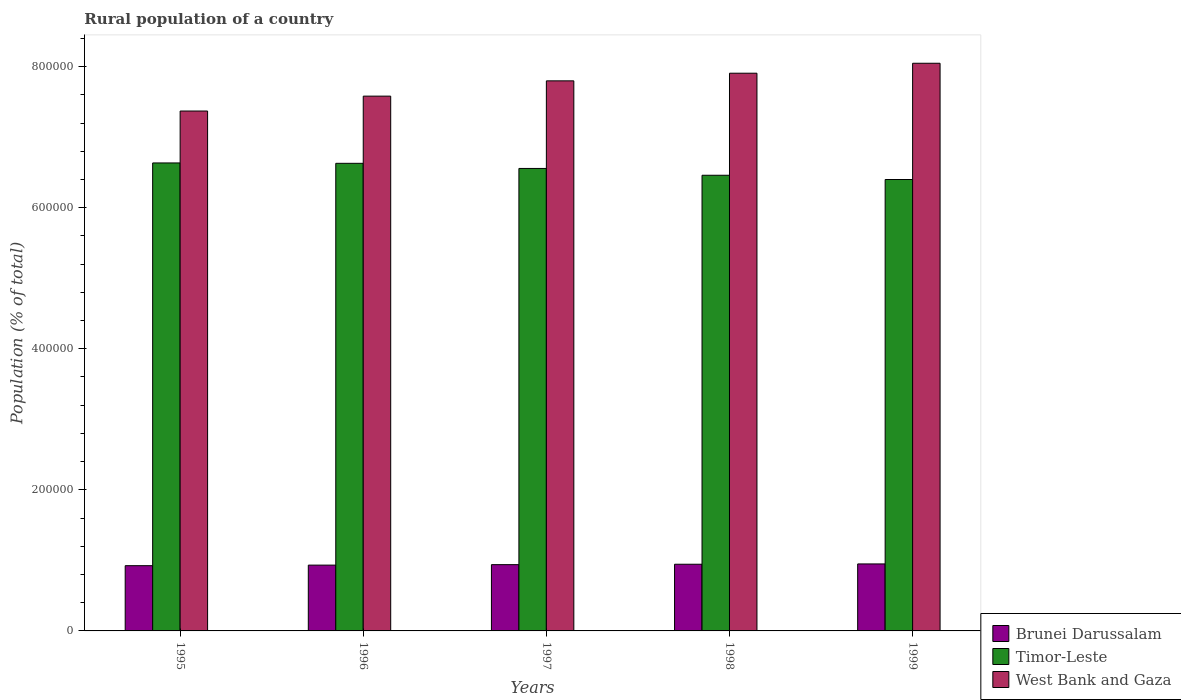How many different coloured bars are there?
Offer a very short reply. 3. How many groups of bars are there?
Give a very brief answer. 5. Are the number of bars on each tick of the X-axis equal?
Offer a very short reply. Yes. How many bars are there on the 4th tick from the left?
Ensure brevity in your answer.  3. How many bars are there on the 1st tick from the right?
Offer a very short reply. 3. In how many cases, is the number of bars for a given year not equal to the number of legend labels?
Provide a succinct answer. 0. What is the rural population in West Bank and Gaza in 1999?
Your answer should be compact. 8.05e+05. Across all years, what is the maximum rural population in Brunei Darussalam?
Your answer should be very brief. 9.50e+04. Across all years, what is the minimum rural population in Brunei Darussalam?
Make the answer very short. 9.25e+04. In which year was the rural population in Brunei Darussalam maximum?
Provide a short and direct response. 1999. What is the total rural population in Timor-Leste in the graph?
Offer a terse response. 3.27e+06. What is the difference between the rural population in Timor-Leste in 1996 and that in 1999?
Ensure brevity in your answer.  2.29e+04. What is the difference between the rural population in Timor-Leste in 1998 and the rural population in West Bank and Gaza in 1999?
Your answer should be compact. -1.59e+05. What is the average rural population in West Bank and Gaza per year?
Keep it short and to the point. 7.74e+05. In the year 1996, what is the difference between the rural population in West Bank and Gaza and rural population in Brunei Darussalam?
Offer a terse response. 6.65e+05. What is the ratio of the rural population in West Bank and Gaza in 1995 to that in 1997?
Your answer should be very brief. 0.95. Is the rural population in Timor-Leste in 1997 less than that in 1999?
Ensure brevity in your answer.  No. Is the difference between the rural population in West Bank and Gaza in 1995 and 1998 greater than the difference between the rural population in Brunei Darussalam in 1995 and 1998?
Your answer should be compact. No. What is the difference between the highest and the second highest rural population in West Bank and Gaza?
Keep it short and to the point. 1.41e+04. What is the difference between the highest and the lowest rural population in Brunei Darussalam?
Your answer should be very brief. 2474. What does the 1st bar from the left in 1995 represents?
Ensure brevity in your answer.  Brunei Darussalam. What does the 1st bar from the right in 1995 represents?
Keep it short and to the point. West Bank and Gaza. Is it the case that in every year, the sum of the rural population in West Bank and Gaza and rural population in Timor-Leste is greater than the rural population in Brunei Darussalam?
Provide a short and direct response. Yes. Are all the bars in the graph horizontal?
Your answer should be compact. No. Are the values on the major ticks of Y-axis written in scientific E-notation?
Provide a succinct answer. No. Does the graph contain grids?
Keep it short and to the point. No. Where does the legend appear in the graph?
Give a very brief answer. Bottom right. How many legend labels are there?
Provide a succinct answer. 3. What is the title of the graph?
Ensure brevity in your answer.  Rural population of a country. What is the label or title of the X-axis?
Offer a very short reply. Years. What is the label or title of the Y-axis?
Offer a very short reply. Population (% of total). What is the Population (% of total) of Brunei Darussalam in 1995?
Offer a terse response. 9.25e+04. What is the Population (% of total) of Timor-Leste in 1995?
Offer a very short reply. 6.63e+05. What is the Population (% of total) in West Bank and Gaza in 1995?
Keep it short and to the point. 7.37e+05. What is the Population (% of total) in Brunei Darussalam in 1996?
Keep it short and to the point. 9.33e+04. What is the Population (% of total) in Timor-Leste in 1996?
Your response must be concise. 6.63e+05. What is the Population (% of total) of West Bank and Gaza in 1996?
Your answer should be compact. 7.58e+05. What is the Population (% of total) of Brunei Darussalam in 1997?
Make the answer very short. 9.40e+04. What is the Population (% of total) in Timor-Leste in 1997?
Ensure brevity in your answer.  6.56e+05. What is the Population (% of total) of West Bank and Gaza in 1997?
Your answer should be compact. 7.80e+05. What is the Population (% of total) of Brunei Darussalam in 1998?
Your answer should be very brief. 9.45e+04. What is the Population (% of total) in Timor-Leste in 1998?
Give a very brief answer. 6.46e+05. What is the Population (% of total) of West Bank and Gaza in 1998?
Your response must be concise. 7.91e+05. What is the Population (% of total) in Brunei Darussalam in 1999?
Offer a terse response. 9.50e+04. What is the Population (% of total) of Timor-Leste in 1999?
Ensure brevity in your answer.  6.40e+05. What is the Population (% of total) of West Bank and Gaza in 1999?
Your answer should be compact. 8.05e+05. Across all years, what is the maximum Population (% of total) of Brunei Darussalam?
Make the answer very short. 9.50e+04. Across all years, what is the maximum Population (% of total) of Timor-Leste?
Offer a terse response. 6.63e+05. Across all years, what is the maximum Population (% of total) of West Bank and Gaza?
Give a very brief answer. 8.05e+05. Across all years, what is the minimum Population (% of total) of Brunei Darussalam?
Your answer should be very brief. 9.25e+04. Across all years, what is the minimum Population (% of total) of Timor-Leste?
Make the answer very short. 6.40e+05. Across all years, what is the minimum Population (% of total) of West Bank and Gaza?
Provide a short and direct response. 7.37e+05. What is the total Population (% of total) of Brunei Darussalam in the graph?
Your response must be concise. 4.69e+05. What is the total Population (% of total) of Timor-Leste in the graph?
Ensure brevity in your answer.  3.27e+06. What is the total Population (% of total) of West Bank and Gaza in the graph?
Offer a very short reply. 3.87e+06. What is the difference between the Population (% of total) of Brunei Darussalam in 1995 and that in 1996?
Provide a short and direct response. -778. What is the difference between the Population (% of total) in Timor-Leste in 1995 and that in 1996?
Make the answer very short. 546. What is the difference between the Population (% of total) of West Bank and Gaza in 1995 and that in 1996?
Offer a terse response. -2.11e+04. What is the difference between the Population (% of total) in Brunei Darussalam in 1995 and that in 1997?
Provide a short and direct response. -1455. What is the difference between the Population (% of total) in Timor-Leste in 1995 and that in 1997?
Your answer should be very brief. 7807. What is the difference between the Population (% of total) in West Bank and Gaza in 1995 and that in 1997?
Provide a succinct answer. -4.28e+04. What is the difference between the Population (% of total) of Brunei Darussalam in 1995 and that in 1998?
Your answer should be compact. -2020. What is the difference between the Population (% of total) of Timor-Leste in 1995 and that in 1998?
Offer a terse response. 1.75e+04. What is the difference between the Population (% of total) of West Bank and Gaza in 1995 and that in 1998?
Give a very brief answer. -5.36e+04. What is the difference between the Population (% of total) of Brunei Darussalam in 1995 and that in 1999?
Offer a terse response. -2474. What is the difference between the Population (% of total) of Timor-Leste in 1995 and that in 1999?
Your answer should be very brief. 2.35e+04. What is the difference between the Population (% of total) in West Bank and Gaza in 1995 and that in 1999?
Your response must be concise. -6.77e+04. What is the difference between the Population (% of total) in Brunei Darussalam in 1996 and that in 1997?
Offer a terse response. -677. What is the difference between the Population (% of total) in Timor-Leste in 1996 and that in 1997?
Your response must be concise. 7261. What is the difference between the Population (% of total) of West Bank and Gaza in 1996 and that in 1997?
Provide a succinct answer. -2.17e+04. What is the difference between the Population (% of total) in Brunei Darussalam in 1996 and that in 1998?
Offer a very short reply. -1242. What is the difference between the Population (% of total) in Timor-Leste in 1996 and that in 1998?
Ensure brevity in your answer.  1.69e+04. What is the difference between the Population (% of total) of West Bank and Gaza in 1996 and that in 1998?
Your answer should be compact. -3.25e+04. What is the difference between the Population (% of total) of Brunei Darussalam in 1996 and that in 1999?
Give a very brief answer. -1696. What is the difference between the Population (% of total) in Timor-Leste in 1996 and that in 1999?
Provide a succinct answer. 2.29e+04. What is the difference between the Population (% of total) in West Bank and Gaza in 1996 and that in 1999?
Your answer should be compact. -4.66e+04. What is the difference between the Population (% of total) of Brunei Darussalam in 1997 and that in 1998?
Give a very brief answer. -565. What is the difference between the Population (% of total) in Timor-Leste in 1997 and that in 1998?
Provide a succinct answer. 9651. What is the difference between the Population (% of total) of West Bank and Gaza in 1997 and that in 1998?
Your answer should be very brief. -1.08e+04. What is the difference between the Population (% of total) in Brunei Darussalam in 1997 and that in 1999?
Offer a very short reply. -1019. What is the difference between the Population (% of total) of Timor-Leste in 1997 and that in 1999?
Keep it short and to the point. 1.57e+04. What is the difference between the Population (% of total) in West Bank and Gaza in 1997 and that in 1999?
Keep it short and to the point. -2.49e+04. What is the difference between the Population (% of total) in Brunei Darussalam in 1998 and that in 1999?
Your answer should be very brief. -454. What is the difference between the Population (% of total) of Timor-Leste in 1998 and that in 1999?
Ensure brevity in your answer.  6026. What is the difference between the Population (% of total) in West Bank and Gaza in 1998 and that in 1999?
Offer a very short reply. -1.41e+04. What is the difference between the Population (% of total) in Brunei Darussalam in 1995 and the Population (% of total) in Timor-Leste in 1996?
Keep it short and to the point. -5.70e+05. What is the difference between the Population (% of total) in Brunei Darussalam in 1995 and the Population (% of total) in West Bank and Gaza in 1996?
Make the answer very short. -6.66e+05. What is the difference between the Population (% of total) of Timor-Leste in 1995 and the Population (% of total) of West Bank and Gaza in 1996?
Your response must be concise. -9.47e+04. What is the difference between the Population (% of total) in Brunei Darussalam in 1995 and the Population (% of total) in Timor-Leste in 1997?
Your answer should be compact. -5.63e+05. What is the difference between the Population (% of total) in Brunei Darussalam in 1995 and the Population (% of total) in West Bank and Gaza in 1997?
Offer a very short reply. -6.87e+05. What is the difference between the Population (% of total) of Timor-Leste in 1995 and the Population (% of total) of West Bank and Gaza in 1997?
Make the answer very short. -1.16e+05. What is the difference between the Population (% of total) of Brunei Darussalam in 1995 and the Population (% of total) of Timor-Leste in 1998?
Offer a terse response. -5.53e+05. What is the difference between the Population (% of total) in Brunei Darussalam in 1995 and the Population (% of total) in West Bank and Gaza in 1998?
Offer a terse response. -6.98e+05. What is the difference between the Population (% of total) in Timor-Leste in 1995 and the Population (% of total) in West Bank and Gaza in 1998?
Give a very brief answer. -1.27e+05. What is the difference between the Population (% of total) of Brunei Darussalam in 1995 and the Population (% of total) of Timor-Leste in 1999?
Provide a short and direct response. -5.47e+05. What is the difference between the Population (% of total) of Brunei Darussalam in 1995 and the Population (% of total) of West Bank and Gaza in 1999?
Make the answer very short. -7.12e+05. What is the difference between the Population (% of total) of Timor-Leste in 1995 and the Population (% of total) of West Bank and Gaza in 1999?
Give a very brief answer. -1.41e+05. What is the difference between the Population (% of total) in Brunei Darussalam in 1996 and the Population (% of total) in Timor-Leste in 1997?
Your answer should be compact. -5.62e+05. What is the difference between the Population (% of total) of Brunei Darussalam in 1996 and the Population (% of total) of West Bank and Gaza in 1997?
Offer a terse response. -6.87e+05. What is the difference between the Population (% of total) in Timor-Leste in 1996 and the Population (% of total) in West Bank and Gaza in 1997?
Offer a terse response. -1.17e+05. What is the difference between the Population (% of total) in Brunei Darussalam in 1996 and the Population (% of total) in Timor-Leste in 1998?
Your answer should be compact. -5.53e+05. What is the difference between the Population (% of total) in Brunei Darussalam in 1996 and the Population (% of total) in West Bank and Gaza in 1998?
Offer a terse response. -6.97e+05. What is the difference between the Population (% of total) of Timor-Leste in 1996 and the Population (% of total) of West Bank and Gaza in 1998?
Provide a succinct answer. -1.28e+05. What is the difference between the Population (% of total) in Brunei Darussalam in 1996 and the Population (% of total) in Timor-Leste in 1999?
Your answer should be compact. -5.47e+05. What is the difference between the Population (% of total) in Brunei Darussalam in 1996 and the Population (% of total) in West Bank and Gaza in 1999?
Provide a short and direct response. -7.11e+05. What is the difference between the Population (% of total) in Timor-Leste in 1996 and the Population (% of total) in West Bank and Gaza in 1999?
Provide a succinct answer. -1.42e+05. What is the difference between the Population (% of total) in Brunei Darussalam in 1997 and the Population (% of total) in Timor-Leste in 1998?
Give a very brief answer. -5.52e+05. What is the difference between the Population (% of total) of Brunei Darussalam in 1997 and the Population (% of total) of West Bank and Gaza in 1998?
Give a very brief answer. -6.97e+05. What is the difference between the Population (% of total) of Timor-Leste in 1997 and the Population (% of total) of West Bank and Gaza in 1998?
Give a very brief answer. -1.35e+05. What is the difference between the Population (% of total) of Brunei Darussalam in 1997 and the Population (% of total) of Timor-Leste in 1999?
Your response must be concise. -5.46e+05. What is the difference between the Population (% of total) of Brunei Darussalam in 1997 and the Population (% of total) of West Bank and Gaza in 1999?
Your answer should be very brief. -7.11e+05. What is the difference between the Population (% of total) of Timor-Leste in 1997 and the Population (% of total) of West Bank and Gaza in 1999?
Provide a succinct answer. -1.49e+05. What is the difference between the Population (% of total) of Brunei Darussalam in 1998 and the Population (% of total) of Timor-Leste in 1999?
Offer a very short reply. -5.45e+05. What is the difference between the Population (% of total) of Brunei Darussalam in 1998 and the Population (% of total) of West Bank and Gaza in 1999?
Your answer should be very brief. -7.10e+05. What is the difference between the Population (% of total) of Timor-Leste in 1998 and the Population (% of total) of West Bank and Gaza in 1999?
Your response must be concise. -1.59e+05. What is the average Population (% of total) in Brunei Darussalam per year?
Provide a succinct answer. 9.38e+04. What is the average Population (% of total) in Timor-Leste per year?
Your answer should be compact. 6.54e+05. What is the average Population (% of total) in West Bank and Gaza per year?
Offer a very short reply. 7.74e+05. In the year 1995, what is the difference between the Population (% of total) of Brunei Darussalam and Population (% of total) of Timor-Leste?
Offer a very short reply. -5.71e+05. In the year 1995, what is the difference between the Population (% of total) in Brunei Darussalam and Population (% of total) in West Bank and Gaza?
Make the answer very short. -6.45e+05. In the year 1995, what is the difference between the Population (% of total) of Timor-Leste and Population (% of total) of West Bank and Gaza?
Offer a terse response. -7.36e+04. In the year 1996, what is the difference between the Population (% of total) in Brunei Darussalam and Population (% of total) in Timor-Leste?
Keep it short and to the point. -5.70e+05. In the year 1996, what is the difference between the Population (% of total) in Brunei Darussalam and Population (% of total) in West Bank and Gaza?
Your response must be concise. -6.65e+05. In the year 1996, what is the difference between the Population (% of total) in Timor-Leste and Population (% of total) in West Bank and Gaza?
Offer a very short reply. -9.53e+04. In the year 1997, what is the difference between the Population (% of total) in Brunei Darussalam and Population (% of total) in Timor-Leste?
Your answer should be compact. -5.62e+05. In the year 1997, what is the difference between the Population (% of total) in Brunei Darussalam and Population (% of total) in West Bank and Gaza?
Provide a succinct answer. -6.86e+05. In the year 1997, what is the difference between the Population (% of total) of Timor-Leste and Population (% of total) of West Bank and Gaza?
Ensure brevity in your answer.  -1.24e+05. In the year 1998, what is the difference between the Population (% of total) of Brunei Darussalam and Population (% of total) of Timor-Leste?
Your answer should be very brief. -5.51e+05. In the year 1998, what is the difference between the Population (% of total) in Brunei Darussalam and Population (% of total) in West Bank and Gaza?
Offer a terse response. -6.96e+05. In the year 1998, what is the difference between the Population (% of total) in Timor-Leste and Population (% of total) in West Bank and Gaza?
Provide a short and direct response. -1.45e+05. In the year 1999, what is the difference between the Population (% of total) of Brunei Darussalam and Population (% of total) of Timor-Leste?
Ensure brevity in your answer.  -5.45e+05. In the year 1999, what is the difference between the Population (% of total) in Brunei Darussalam and Population (% of total) in West Bank and Gaza?
Make the answer very short. -7.10e+05. In the year 1999, what is the difference between the Population (% of total) of Timor-Leste and Population (% of total) of West Bank and Gaza?
Offer a very short reply. -1.65e+05. What is the ratio of the Population (% of total) of West Bank and Gaza in 1995 to that in 1996?
Your answer should be compact. 0.97. What is the ratio of the Population (% of total) in Brunei Darussalam in 1995 to that in 1997?
Give a very brief answer. 0.98. What is the ratio of the Population (% of total) in Timor-Leste in 1995 to that in 1997?
Your response must be concise. 1.01. What is the ratio of the Population (% of total) in West Bank and Gaza in 1995 to that in 1997?
Offer a very short reply. 0.95. What is the ratio of the Population (% of total) of Brunei Darussalam in 1995 to that in 1998?
Your response must be concise. 0.98. What is the ratio of the Population (% of total) in Timor-Leste in 1995 to that in 1998?
Ensure brevity in your answer.  1.03. What is the ratio of the Population (% of total) in West Bank and Gaza in 1995 to that in 1998?
Your response must be concise. 0.93. What is the ratio of the Population (% of total) of Timor-Leste in 1995 to that in 1999?
Give a very brief answer. 1.04. What is the ratio of the Population (% of total) in West Bank and Gaza in 1995 to that in 1999?
Give a very brief answer. 0.92. What is the ratio of the Population (% of total) in Timor-Leste in 1996 to that in 1997?
Offer a terse response. 1.01. What is the ratio of the Population (% of total) of West Bank and Gaza in 1996 to that in 1997?
Offer a very short reply. 0.97. What is the ratio of the Population (% of total) of Brunei Darussalam in 1996 to that in 1998?
Ensure brevity in your answer.  0.99. What is the ratio of the Population (% of total) of Timor-Leste in 1996 to that in 1998?
Offer a terse response. 1.03. What is the ratio of the Population (% of total) of West Bank and Gaza in 1996 to that in 1998?
Provide a short and direct response. 0.96. What is the ratio of the Population (% of total) in Brunei Darussalam in 1996 to that in 1999?
Make the answer very short. 0.98. What is the ratio of the Population (% of total) of Timor-Leste in 1996 to that in 1999?
Offer a very short reply. 1.04. What is the ratio of the Population (% of total) in West Bank and Gaza in 1996 to that in 1999?
Provide a succinct answer. 0.94. What is the ratio of the Population (% of total) in Brunei Darussalam in 1997 to that in 1998?
Offer a terse response. 0.99. What is the ratio of the Population (% of total) of Timor-Leste in 1997 to that in 1998?
Give a very brief answer. 1.01. What is the ratio of the Population (% of total) of West Bank and Gaza in 1997 to that in 1998?
Give a very brief answer. 0.99. What is the ratio of the Population (% of total) of Brunei Darussalam in 1997 to that in 1999?
Offer a terse response. 0.99. What is the ratio of the Population (% of total) of Timor-Leste in 1997 to that in 1999?
Offer a terse response. 1.02. What is the ratio of the Population (% of total) of Brunei Darussalam in 1998 to that in 1999?
Give a very brief answer. 1. What is the ratio of the Population (% of total) of Timor-Leste in 1998 to that in 1999?
Keep it short and to the point. 1.01. What is the ratio of the Population (% of total) in West Bank and Gaza in 1998 to that in 1999?
Your answer should be very brief. 0.98. What is the difference between the highest and the second highest Population (% of total) in Brunei Darussalam?
Keep it short and to the point. 454. What is the difference between the highest and the second highest Population (% of total) of Timor-Leste?
Your answer should be compact. 546. What is the difference between the highest and the second highest Population (% of total) in West Bank and Gaza?
Offer a very short reply. 1.41e+04. What is the difference between the highest and the lowest Population (% of total) of Brunei Darussalam?
Make the answer very short. 2474. What is the difference between the highest and the lowest Population (% of total) in Timor-Leste?
Give a very brief answer. 2.35e+04. What is the difference between the highest and the lowest Population (% of total) of West Bank and Gaza?
Your answer should be very brief. 6.77e+04. 